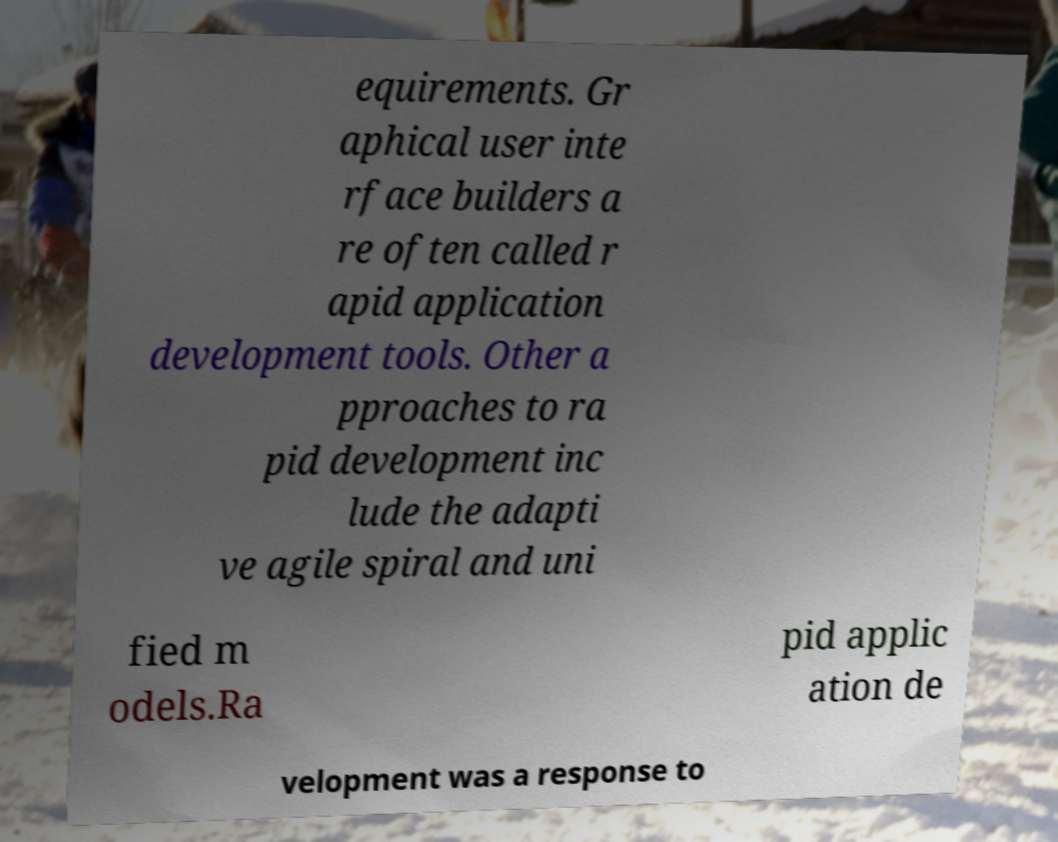Can you accurately transcribe the text from the provided image for me? equirements. Gr aphical user inte rface builders a re often called r apid application development tools. Other a pproaches to ra pid development inc lude the adapti ve agile spiral and uni fied m odels.Ra pid applic ation de velopment was a response to 